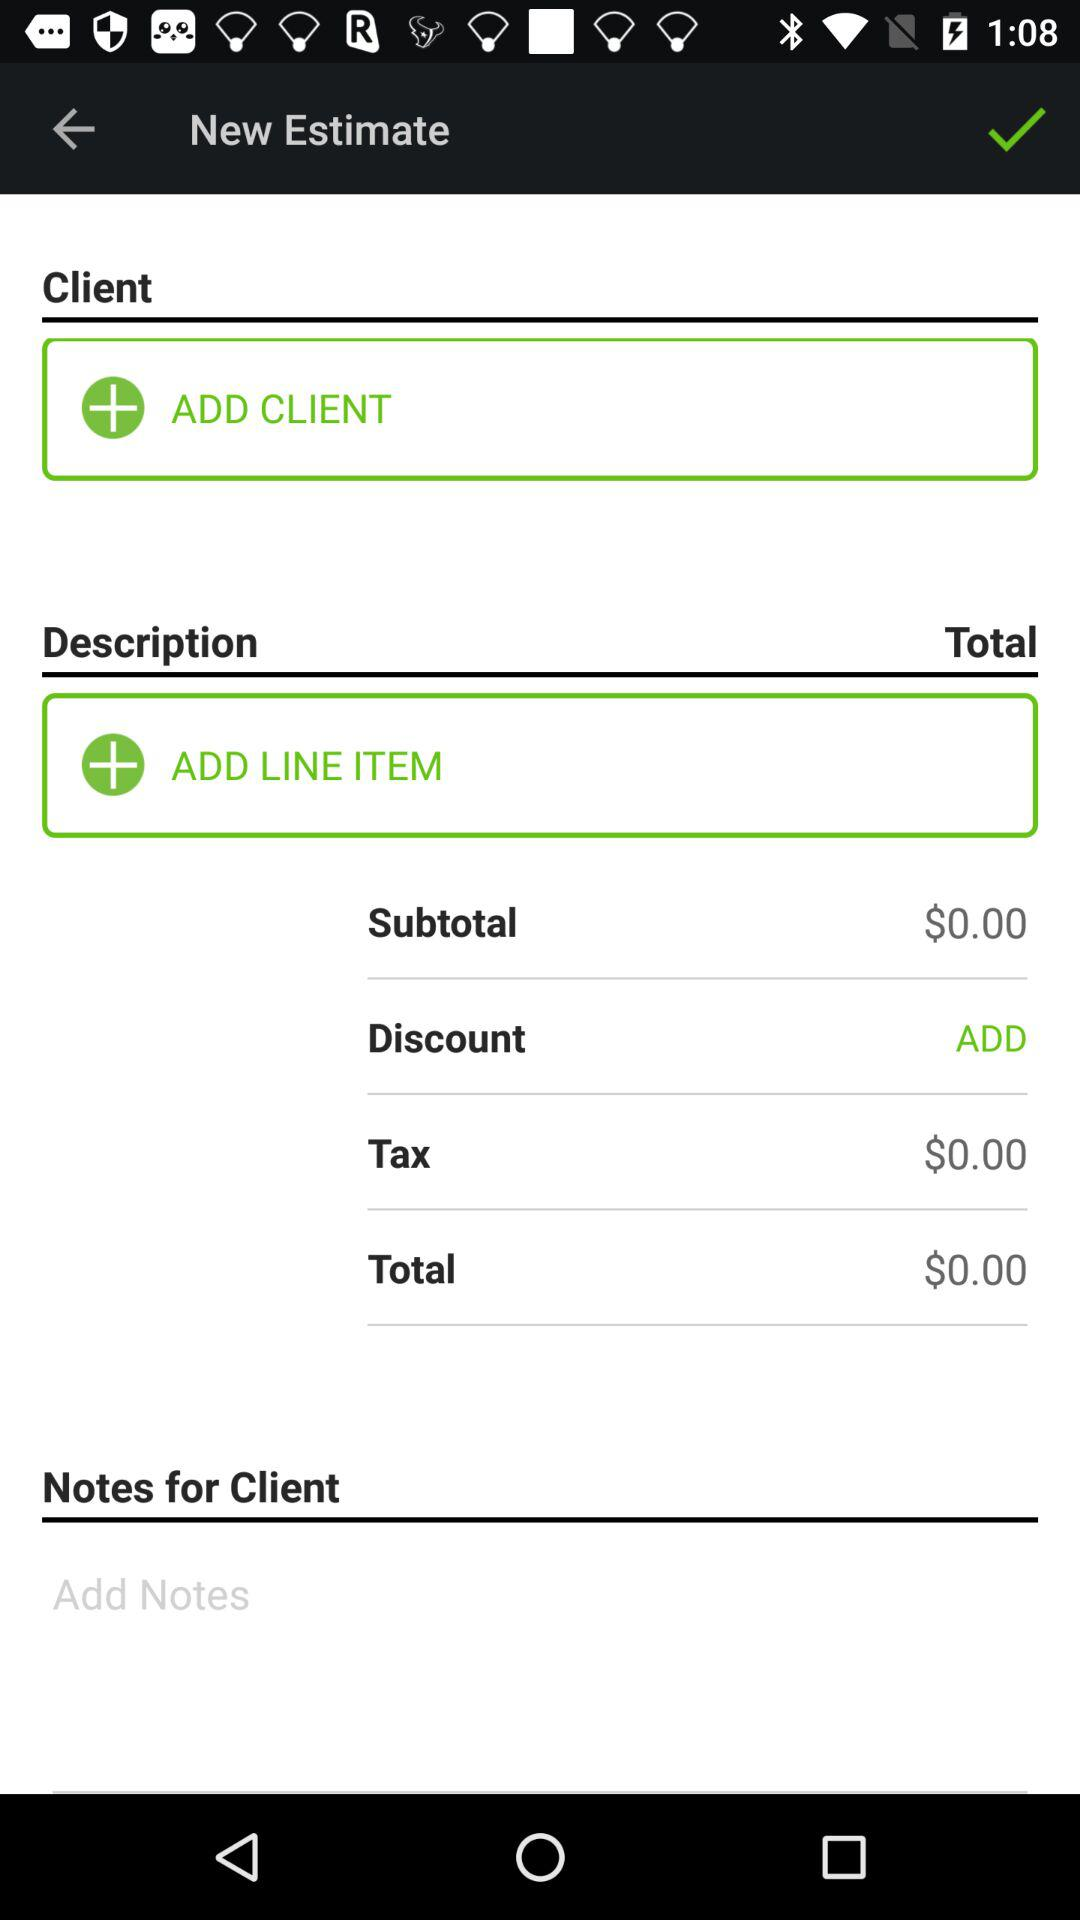What is the total amount of money that the customer will owe?
Answer the question using a single word or phrase. $0.00 